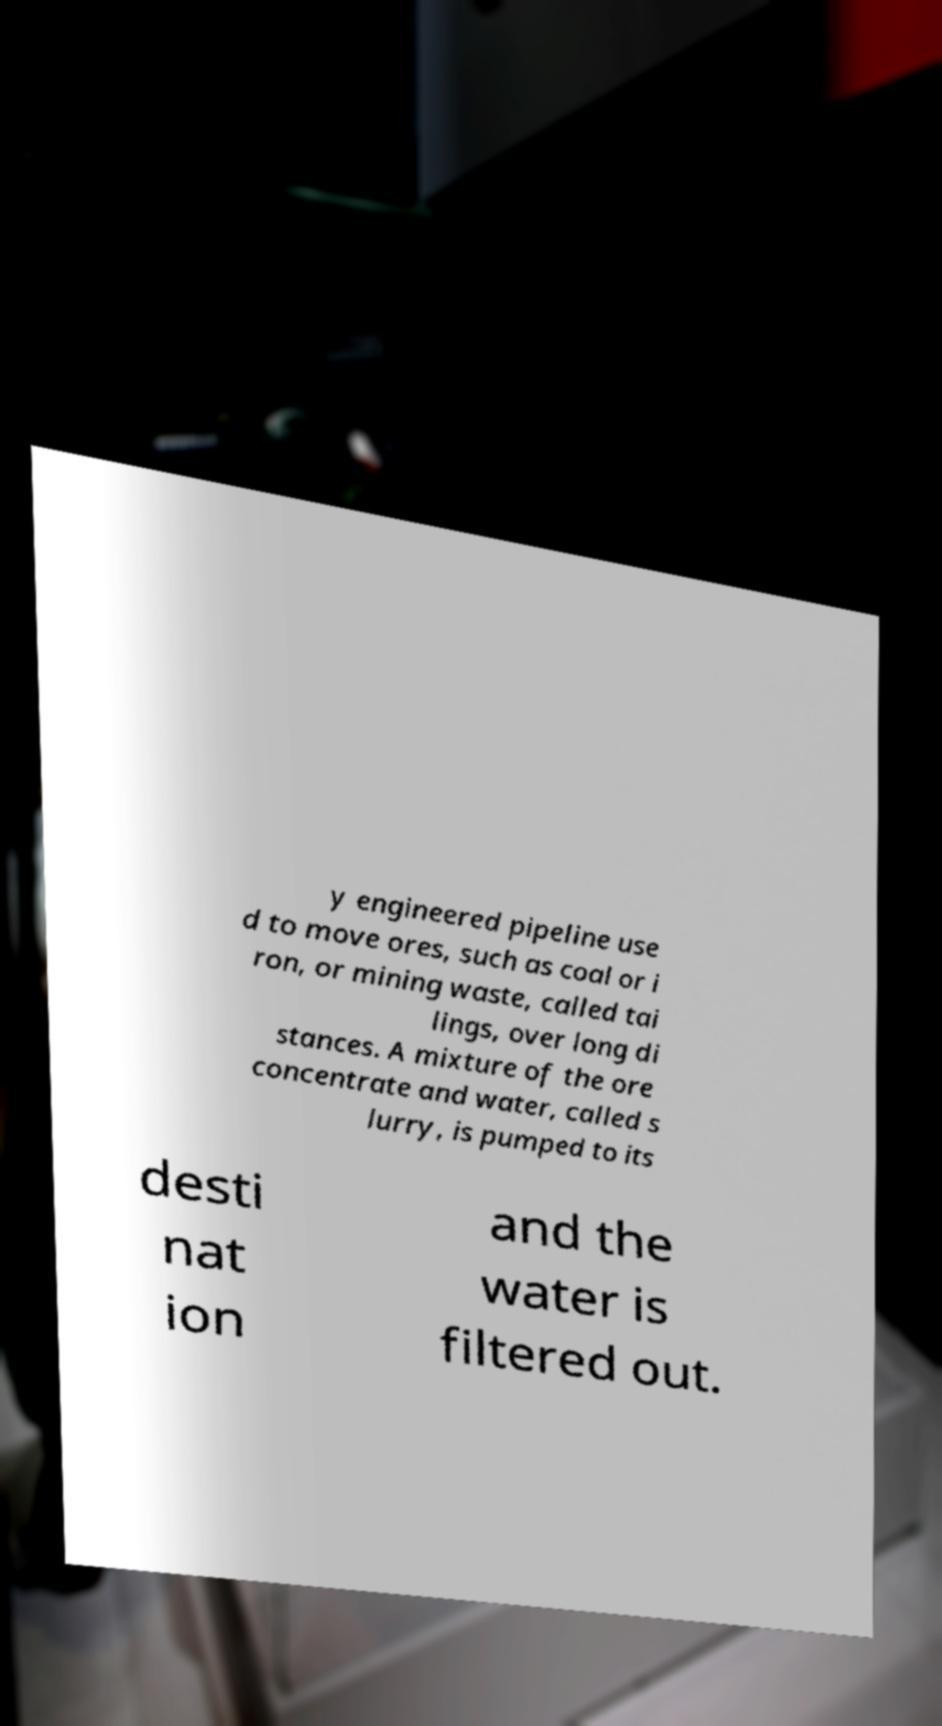What messages or text are displayed in this image? I need them in a readable, typed format. y engineered pipeline use d to move ores, such as coal or i ron, or mining waste, called tai lings, over long di stances. A mixture of the ore concentrate and water, called s lurry, is pumped to its desti nat ion and the water is filtered out. 